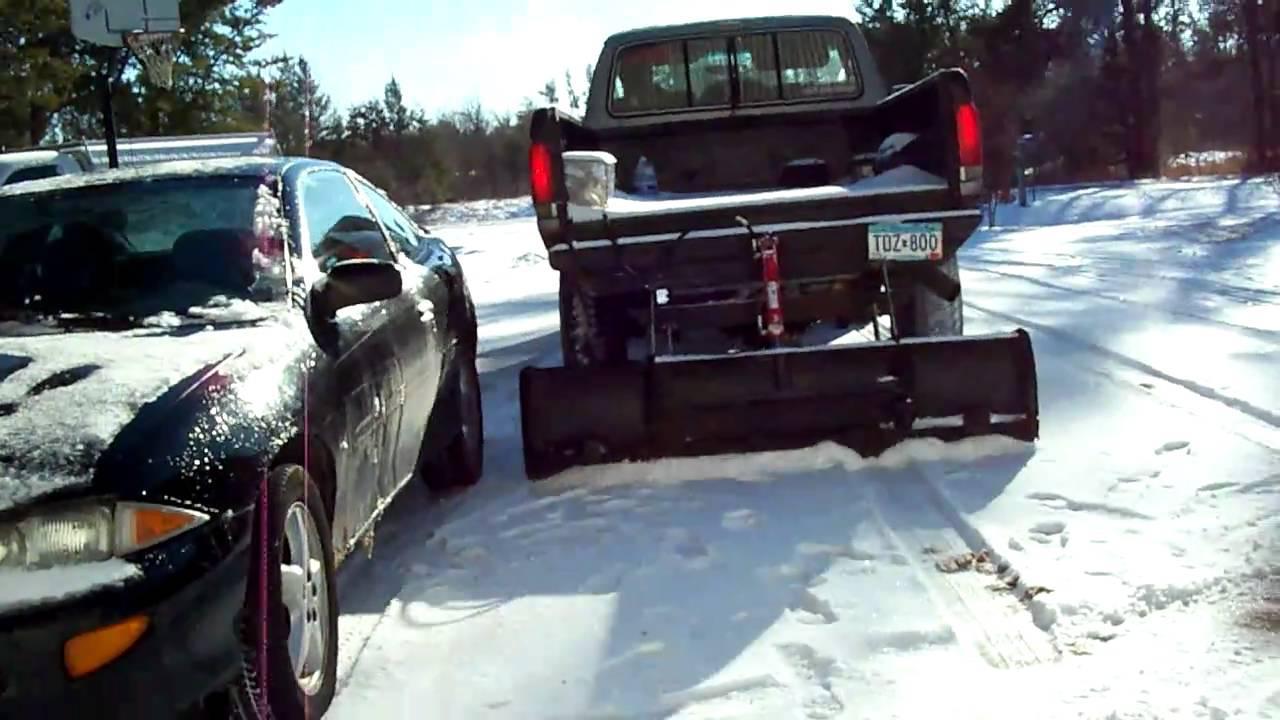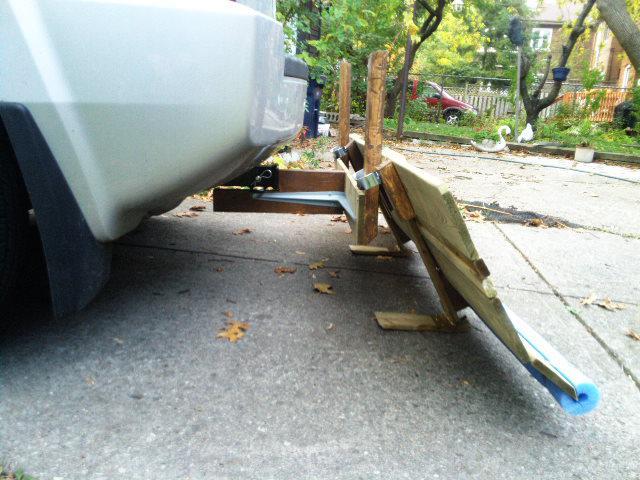The first image is the image on the left, the second image is the image on the right. Evaluate the accuracy of this statement regarding the images: "In one image, a pickup truck with rear mounted snow blade is on a snow covered street.". Is it true? Answer yes or no. Yes. The first image is the image on the left, the second image is the image on the right. Assess this claim about the two images: "An image shows a dark pickup truck pulling a plow on a snowy street.". Correct or not? Answer yes or no. Yes. 